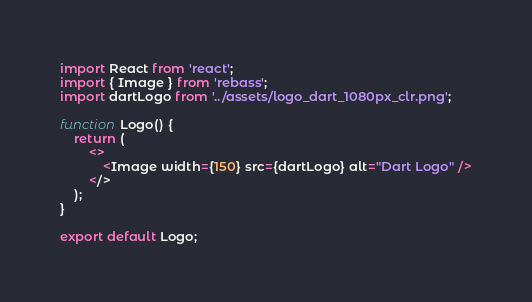Convert code to text. <code><loc_0><loc_0><loc_500><loc_500><_JavaScript_>import React from 'react';
import { Image } from 'rebass';
import dartLogo from '../assets/logo_dart_1080px_clr.png';

function Logo() {
    return (
        <>
            <Image width={150} src={dartLogo} alt="Dart Logo" />
        </>
    );
}

export default Logo;
</code> 